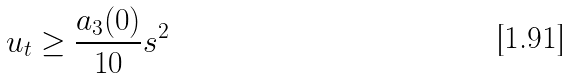<formula> <loc_0><loc_0><loc_500><loc_500>u _ { t } \geq \frac { a _ { 3 } ( 0 ) } { 1 0 } s ^ { 2 }</formula> 